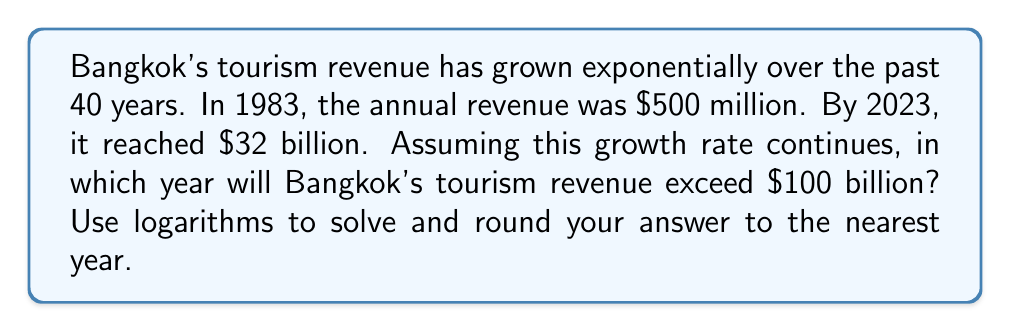Provide a solution to this math problem. Let's approach this step-by-step using logarithms:

1) First, we need to find the annual growth rate. Let's call it $r$. We can use the compound interest formula:

   $A = P(1+r)^t$

   Where $A$ is the final amount, $P$ is the initial amount, $r$ is the annual growth rate, and $t$ is the time in years.

2) Plugging in our values:

   $32 \text{ billion} = 500 \text{ million} \cdot (1+r)^{40}$

3) Simplify:

   $64 = (1+r)^{40}$

4) Take the logarithm of both sides:

   $\log 64 = 40 \log(1+r)$

5) Solve for $r$:

   $\frac{\log 64}{40} = \log(1+r)$
   
   $1+r = 10^{\frac{\log 64}{40}}$
   
   $r = 10^{\frac{\log 64}{40}} - 1 \approx 0.1084$ or about 10.84% per year

6) Now, we need to find when the revenue will exceed $100 billion. Let's call this time $t$:

   $100 \text{ billion} = 32 \text{ billion} \cdot (1.1084)^t$

7) Simplify and take logarithms:

   $\frac{100}{32} = (1.1084)^t$
   
   $\log(\frac{100}{32}) = t \log(1.1084)$

8) Solve for $t$:

   $t = \frac{\log(\frac{100}{32})}{\log(1.1084)} \approx 10.36$ years

9) Since 2023 is our starting point, we add this to 2023:

   $2023 + 10.36 = 2033.36$

10) Rounding to the nearest year gives us 2033.
Answer: 2033 